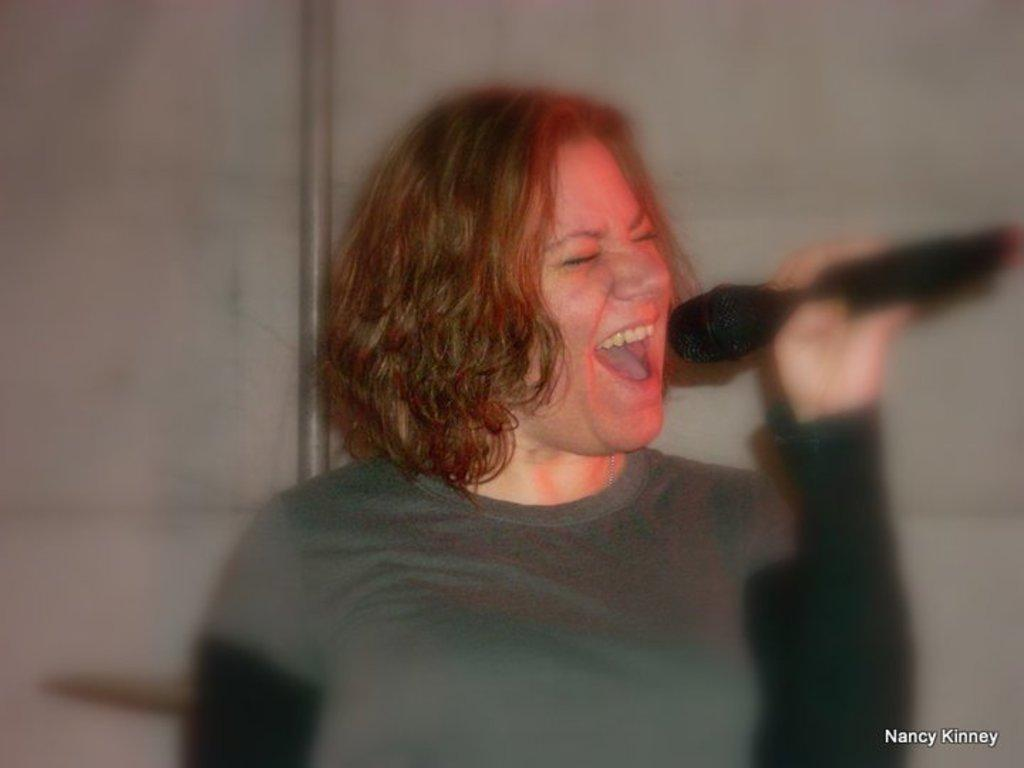What is the main subject of the image? There is a woman in the image. What is the woman doing in the image? The woman is singing a song. What object is the woman holding in the image? The woman is holding a microphone. What can be seen in the background of the image? There is a wall and an iron rod in the background of the image. Can you see any apples floating on the lake in the image? There is no lake or apple present in the image. What type of air is visible in the image? The image does not depict any specific type of air; it simply shows a woman singing with a microphone. 